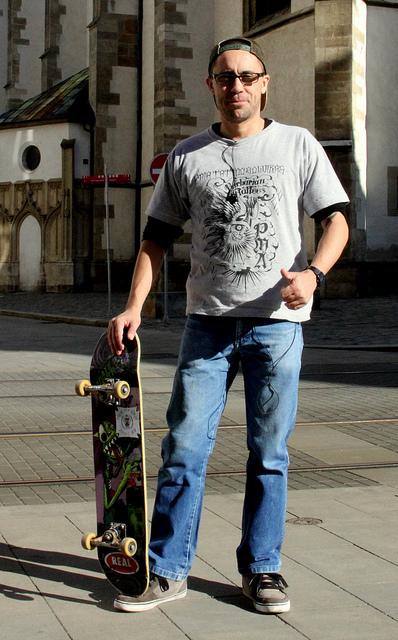What is this man holding in his right hand?
Concise answer only. Skateboard. What color is prominent on the bottom of this person's skateboard?
Quick response, please. Black. What is the man doing with his left hand?
Write a very short answer. Thumbs up. Are this man's feet on the ground?
Answer briefly. Yes. What is resting on the man's foot?
Answer briefly. Skateboard. What is on the man's arm?
Concise answer only. Watch. What is the name of the brown store pictured in the upper portion of this scene?
Give a very brief answer. Unknown. What is holding up the brick on the right side of the boy?
Concise answer only. None. 